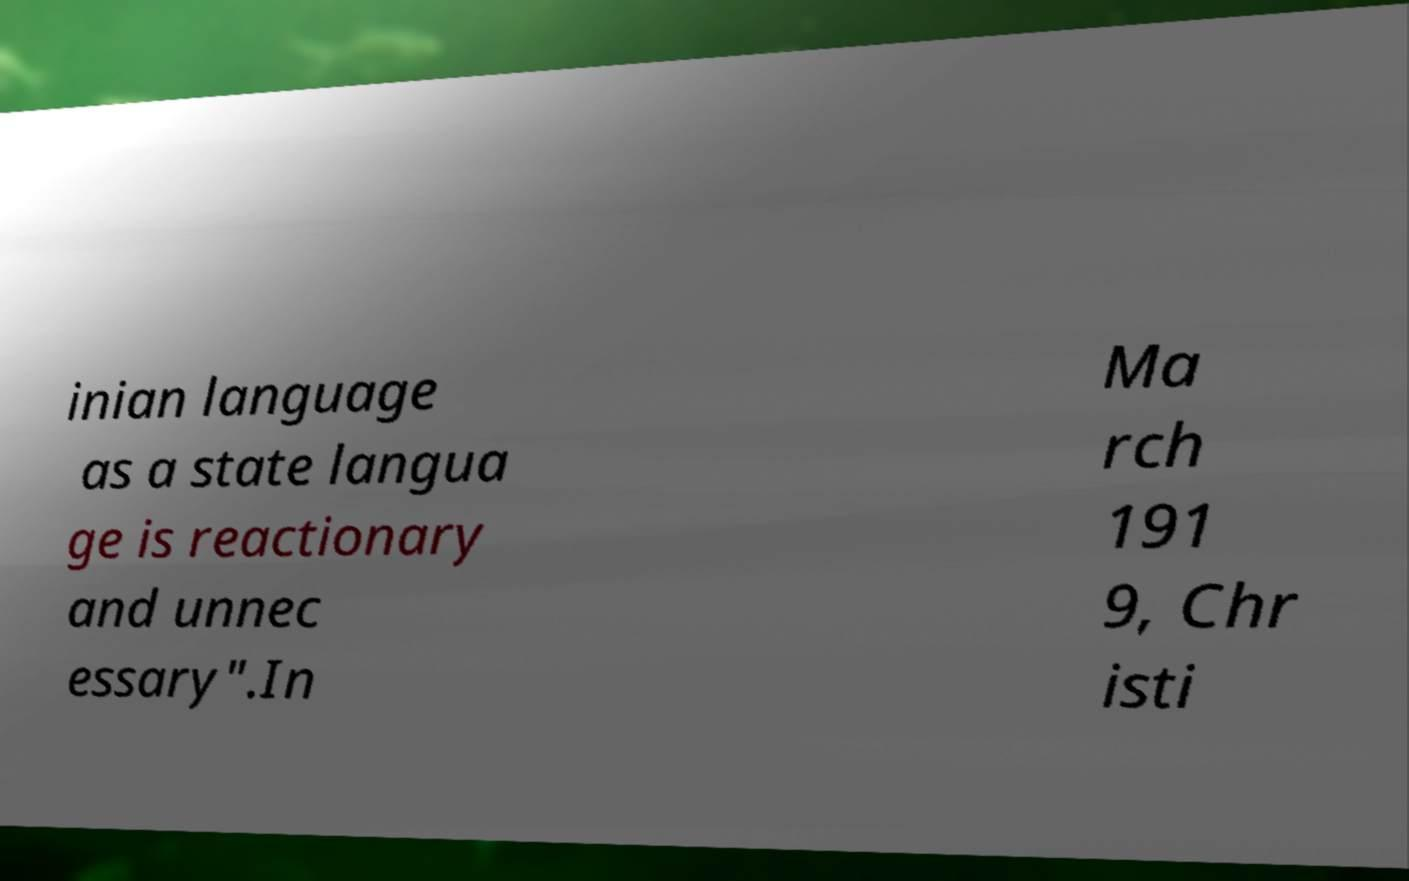Please identify and transcribe the text found in this image. inian language as a state langua ge is reactionary and unnec essary".In Ma rch 191 9, Chr isti 